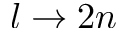<formula> <loc_0><loc_0><loc_500><loc_500>l \rightarrow 2 n</formula> 